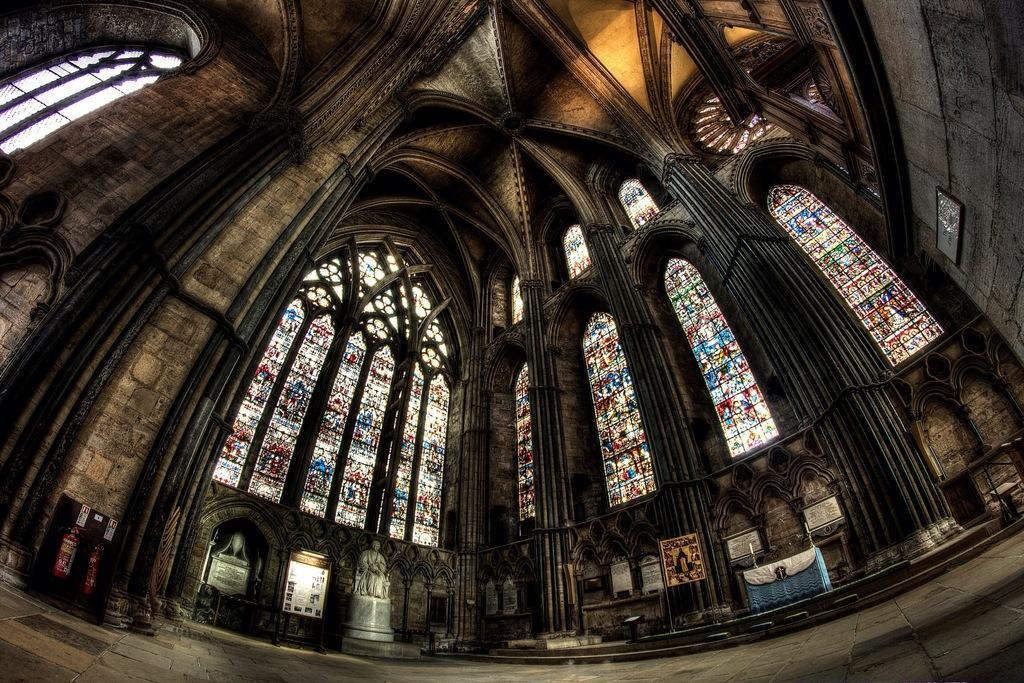How would you summarize this image in a sentence or two? This is an inside view of a church building with big glass windows, statues, pillars, at the top of the image there is a dome and there are fire extinguishers and photo frames. 